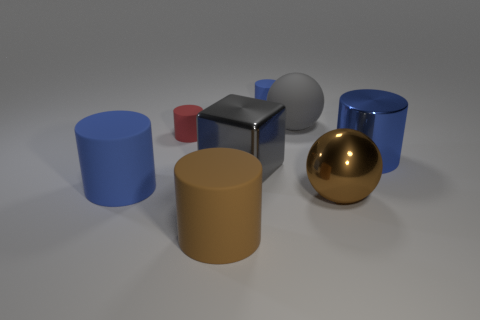There is a brown cylinder that is made of the same material as the big gray ball; what is its size?
Give a very brief answer. Large. Is the red object the same shape as the blue shiny thing?
Ensure brevity in your answer.  Yes. There is a metallic cube that is the same size as the brown matte cylinder; what color is it?
Ensure brevity in your answer.  Gray. There is another thing that is the same shape as the gray matte thing; what is its size?
Your response must be concise. Large. The large gray object that is in front of the rubber ball has what shape?
Your response must be concise. Cube. Do the brown rubber object and the blue thing left of the tiny blue rubber thing have the same shape?
Your response must be concise. Yes. Are there the same number of gray cubes that are on the left side of the tiny red matte thing and matte cylinders in front of the large brown matte thing?
Your response must be concise. Yes. What shape is the large matte thing that is the same color as the big block?
Your answer should be very brief. Sphere. There is a sphere that is behind the big blue metal object; is it the same color as the large metal object that is to the left of the big gray rubber sphere?
Give a very brief answer. Yes. Are there more cylinders right of the large gray rubber ball than green matte objects?
Offer a terse response. Yes. 